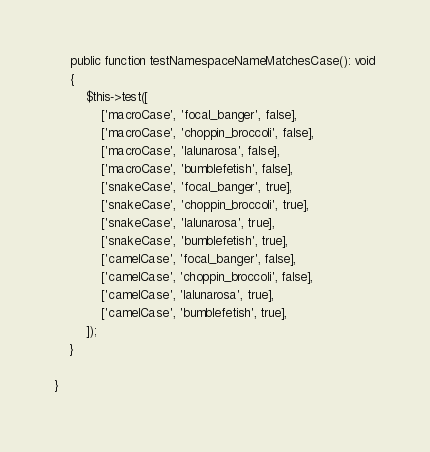Convert code to text. <code><loc_0><loc_0><loc_500><loc_500><_PHP_>
    public function testNamespaceNameMatchesCase(): void
    {
        $this->test([
            ['macroCase', 'focal_banger', false],
            ['macroCase', 'choppin_broccoli', false],
            ['macroCase', 'lalunarosa', false],
            ['macroCase', 'bumblefetish', false],
            ['snakeCase', 'focal_banger', true],
            ['snakeCase', 'choppin_broccoli', true],
            ['snakeCase', 'lalunarosa', true],
            ['snakeCase', 'bumblefetish', true],
            ['camelCase', 'focal_banger', false],
            ['camelCase', 'choppin_broccoli', false],
            ['camelCase', 'lalunarosa', true],
            ['camelCase', 'bumblefetish', true],
        ]);
    }

}
</code> 